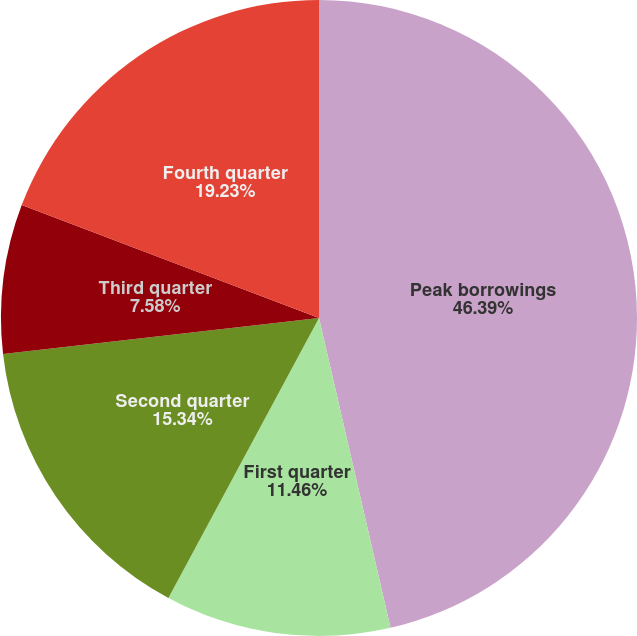Convert chart. <chart><loc_0><loc_0><loc_500><loc_500><pie_chart><fcel>Peak borrowings<fcel>First quarter<fcel>Second quarter<fcel>Third quarter<fcel>Fourth quarter<nl><fcel>46.38%<fcel>11.46%<fcel>15.34%<fcel>7.58%<fcel>19.22%<nl></chart> 